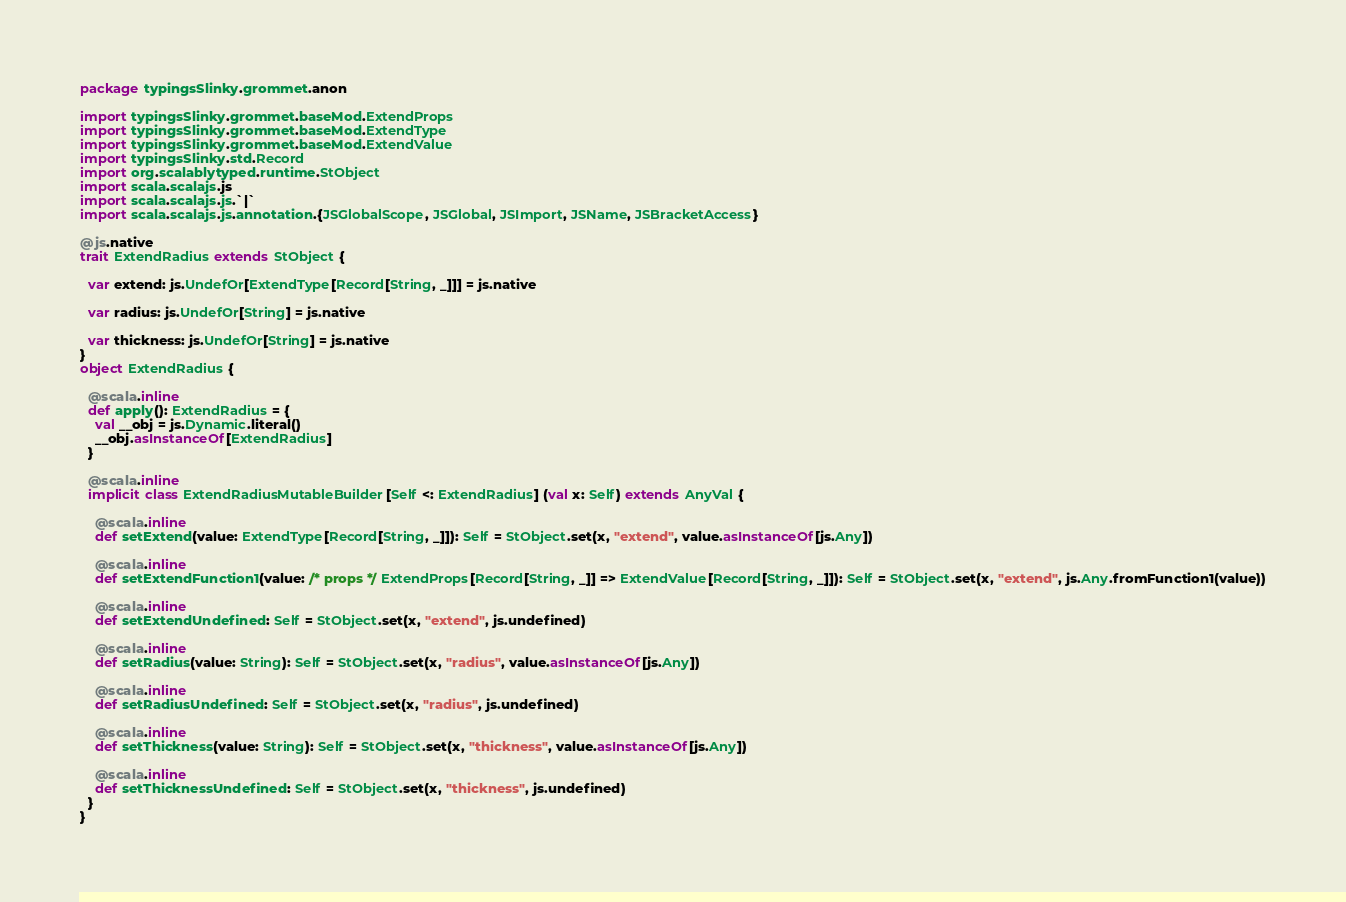<code> <loc_0><loc_0><loc_500><loc_500><_Scala_>package typingsSlinky.grommet.anon

import typingsSlinky.grommet.baseMod.ExtendProps
import typingsSlinky.grommet.baseMod.ExtendType
import typingsSlinky.grommet.baseMod.ExtendValue
import typingsSlinky.std.Record
import org.scalablytyped.runtime.StObject
import scala.scalajs.js
import scala.scalajs.js.`|`
import scala.scalajs.js.annotation.{JSGlobalScope, JSGlobal, JSImport, JSName, JSBracketAccess}

@js.native
trait ExtendRadius extends StObject {
  
  var extend: js.UndefOr[ExtendType[Record[String, _]]] = js.native
  
  var radius: js.UndefOr[String] = js.native
  
  var thickness: js.UndefOr[String] = js.native
}
object ExtendRadius {
  
  @scala.inline
  def apply(): ExtendRadius = {
    val __obj = js.Dynamic.literal()
    __obj.asInstanceOf[ExtendRadius]
  }
  
  @scala.inline
  implicit class ExtendRadiusMutableBuilder[Self <: ExtendRadius] (val x: Self) extends AnyVal {
    
    @scala.inline
    def setExtend(value: ExtendType[Record[String, _]]): Self = StObject.set(x, "extend", value.asInstanceOf[js.Any])
    
    @scala.inline
    def setExtendFunction1(value: /* props */ ExtendProps[Record[String, _]] => ExtendValue[Record[String, _]]): Self = StObject.set(x, "extend", js.Any.fromFunction1(value))
    
    @scala.inline
    def setExtendUndefined: Self = StObject.set(x, "extend", js.undefined)
    
    @scala.inline
    def setRadius(value: String): Self = StObject.set(x, "radius", value.asInstanceOf[js.Any])
    
    @scala.inline
    def setRadiusUndefined: Self = StObject.set(x, "radius", js.undefined)
    
    @scala.inline
    def setThickness(value: String): Self = StObject.set(x, "thickness", value.asInstanceOf[js.Any])
    
    @scala.inline
    def setThicknessUndefined: Self = StObject.set(x, "thickness", js.undefined)
  }
}
</code> 